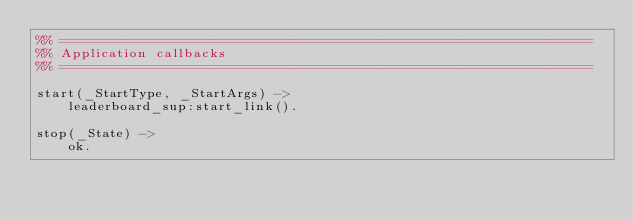<code> <loc_0><loc_0><loc_500><loc_500><_Erlang_>%% ===================================================================
%% Application callbacks
%% ===================================================================

start(_StartType, _StartArgs) ->
    leaderboard_sup:start_link().

stop(_State) ->
    ok.
</code> 